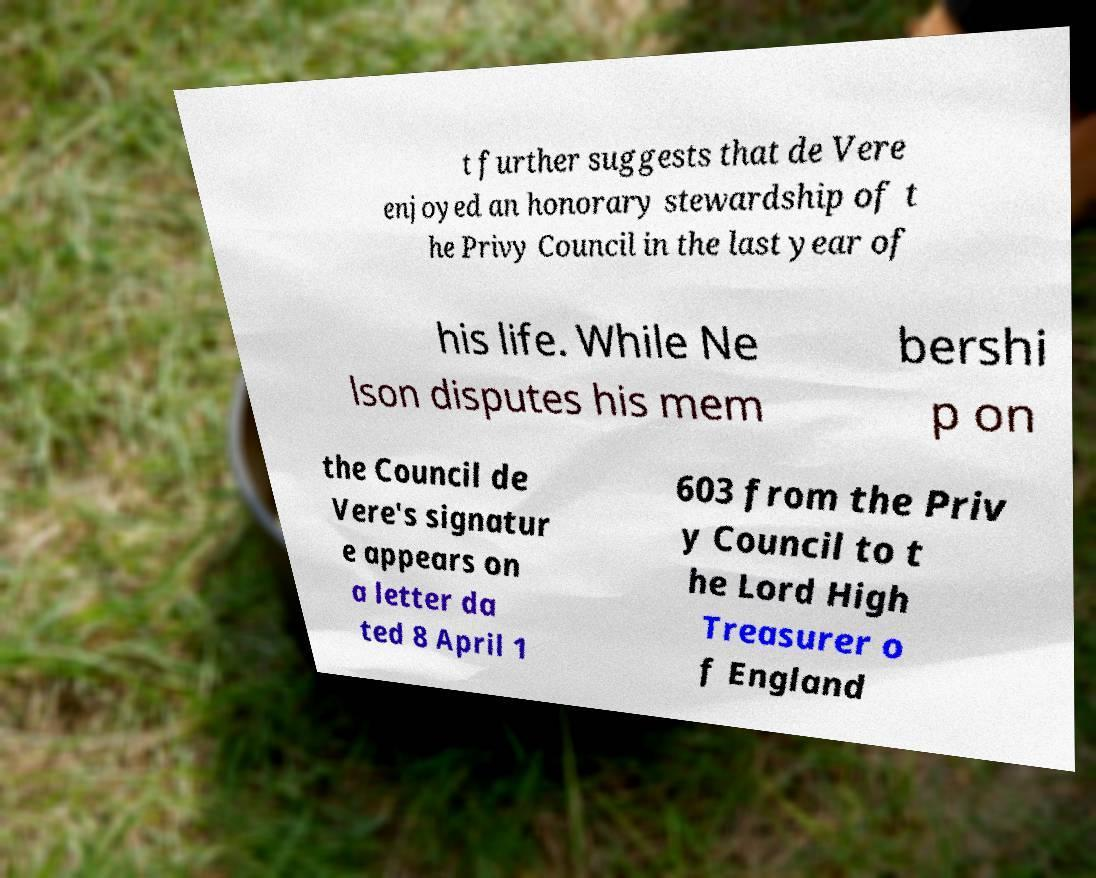Please read and relay the text visible in this image. What does it say? t further suggests that de Vere enjoyed an honorary stewardship of t he Privy Council in the last year of his life. While Ne lson disputes his mem bershi p on the Council de Vere's signatur e appears on a letter da ted 8 April 1 603 from the Priv y Council to t he Lord High Treasurer o f England 